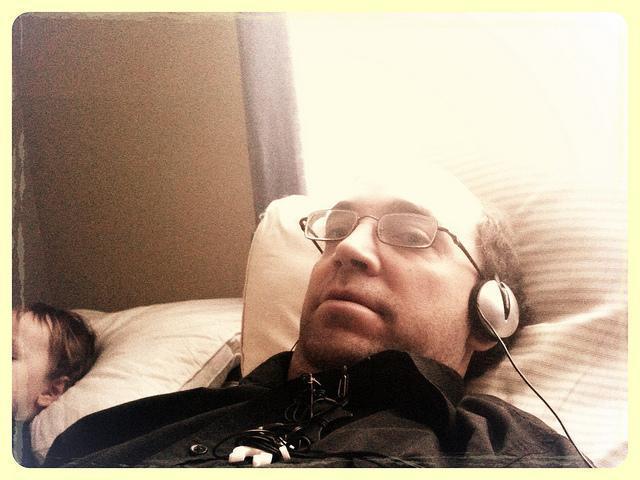How many people are there?
Give a very brief answer. 2. How many giraffes are looking away from the camera?
Give a very brief answer. 0. 